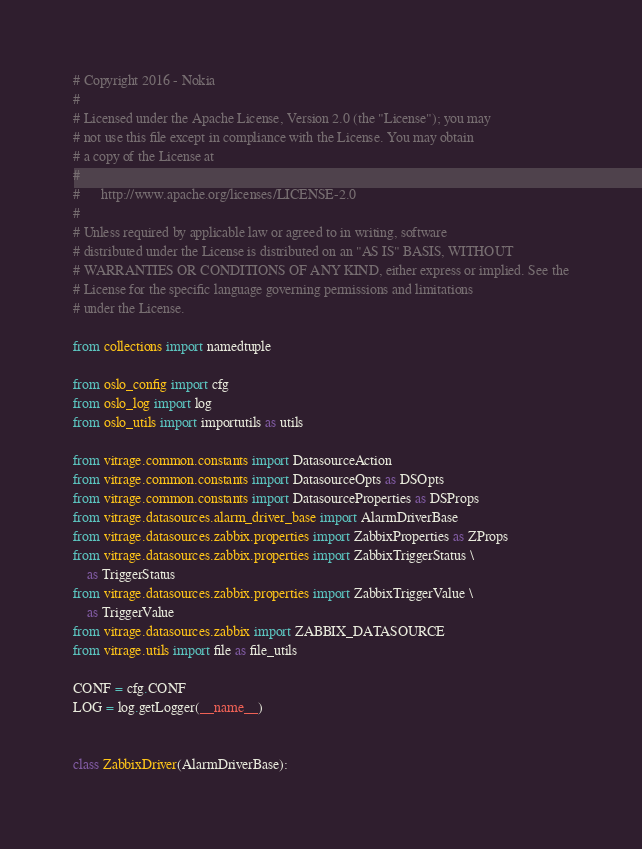<code> <loc_0><loc_0><loc_500><loc_500><_Python_># Copyright 2016 - Nokia
#
# Licensed under the Apache License, Version 2.0 (the "License"); you may
# not use this file except in compliance with the License. You may obtain
# a copy of the License at
#
#      http://www.apache.org/licenses/LICENSE-2.0
#
# Unless required by applicable law or agreed to in writing, software
# distributed under the License is distributed on an "AS IS" BASIS, WITHOUT
# WARRANTIES OR CONDITIONS OF ANY KIND, either express or implied. See the
# License for the specific language governing permissions and limitations
# under the License.

from collections import namedtuple

from oslo_config import cfg
from oslo_log import log
from oslo_utils import importutils as utils

from vitrage.common.constants import DatasourceAction
from vitrage.common.constants import DatasourceOpts as DSOpts
from vitrage.common.constants import DatasourceProperties as DSProps
from vitrage.datasources.alarm_driver_base import AlarmDriverBase
from vitrage.datasources.zabbix.properties import ZabbixProperties as ZProps
from vitrage.datasources.zabbix.properties import ZabbixTriggerStatus \
    as TriggerStatus
from vitrage.datasources.zabbix.properties import ZabbixTriggerValue \
    as TriggerValue
from vitrage.datasources.zabbix import ZABBIX_DATASOURCE
from vitrage.utils import file as file_utils

CONF = cfg.CONF
LOG = log.getLogger(__name__)


class ZabbixDriver(AlarmDriverBase):</code> 